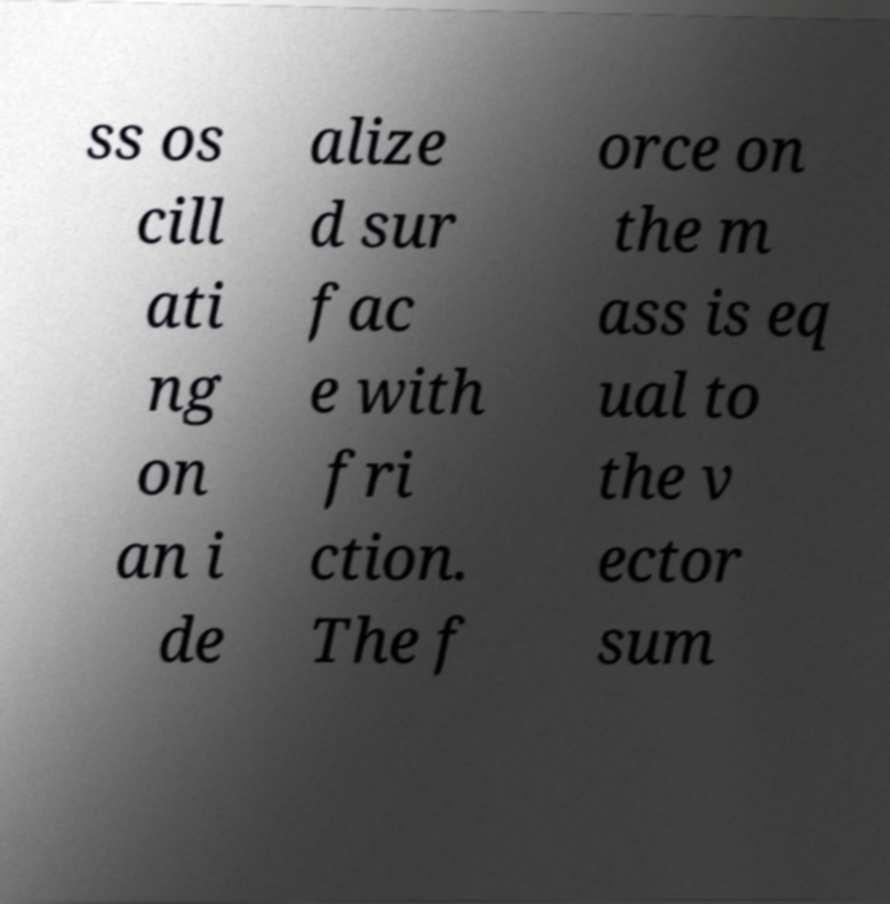For documentation purposes, I need the text within this image transcribed. Could you provide that? ss os cill ati ng on an i de alize d sur fac e with fri ction. The f orce on the m ass is eq ual to the v ector sum 